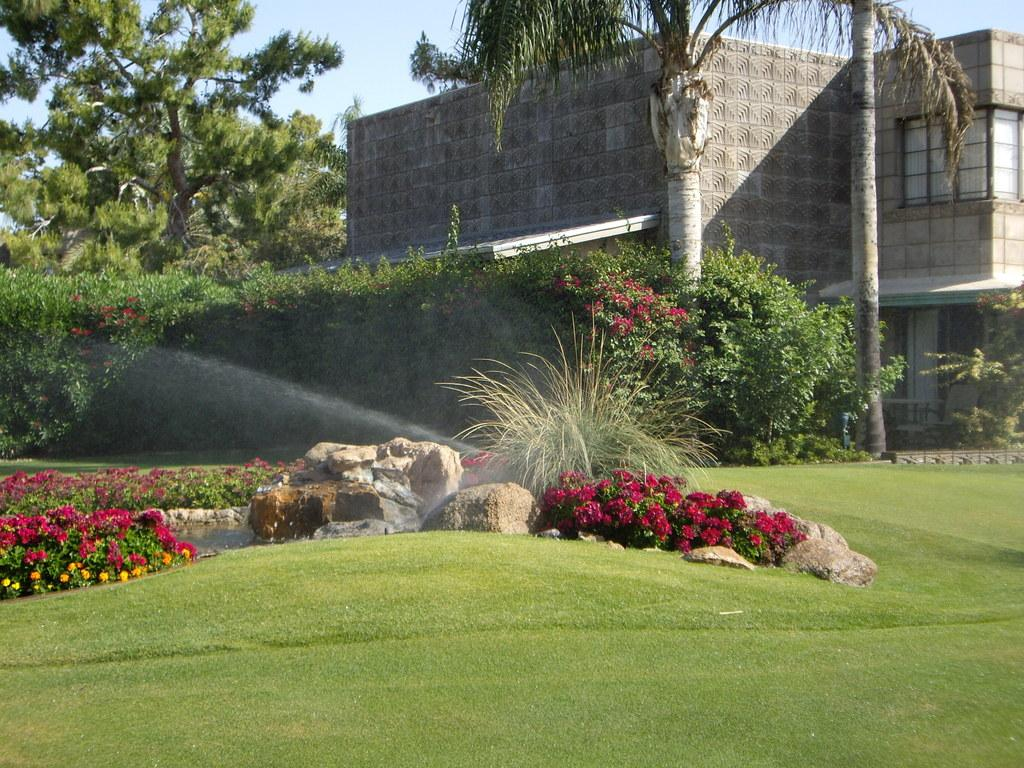What type of outdoor space is depicted in the image? There is a garden in the image. What can be found within the garden? There are flowers, plants, rocks, and water in the garden. What is visible in the background of the image? Trees, a building, and the sky are visible in the background of the image. What type of alarm can be heard going off in the garden? There is no alarm present in the image, and therefore no such sound can be heard. How does the behavior of the robin in the garden affect the plants? There is no robin present in the garden, so its behavior cannot be observed or have any effect on the plants. 